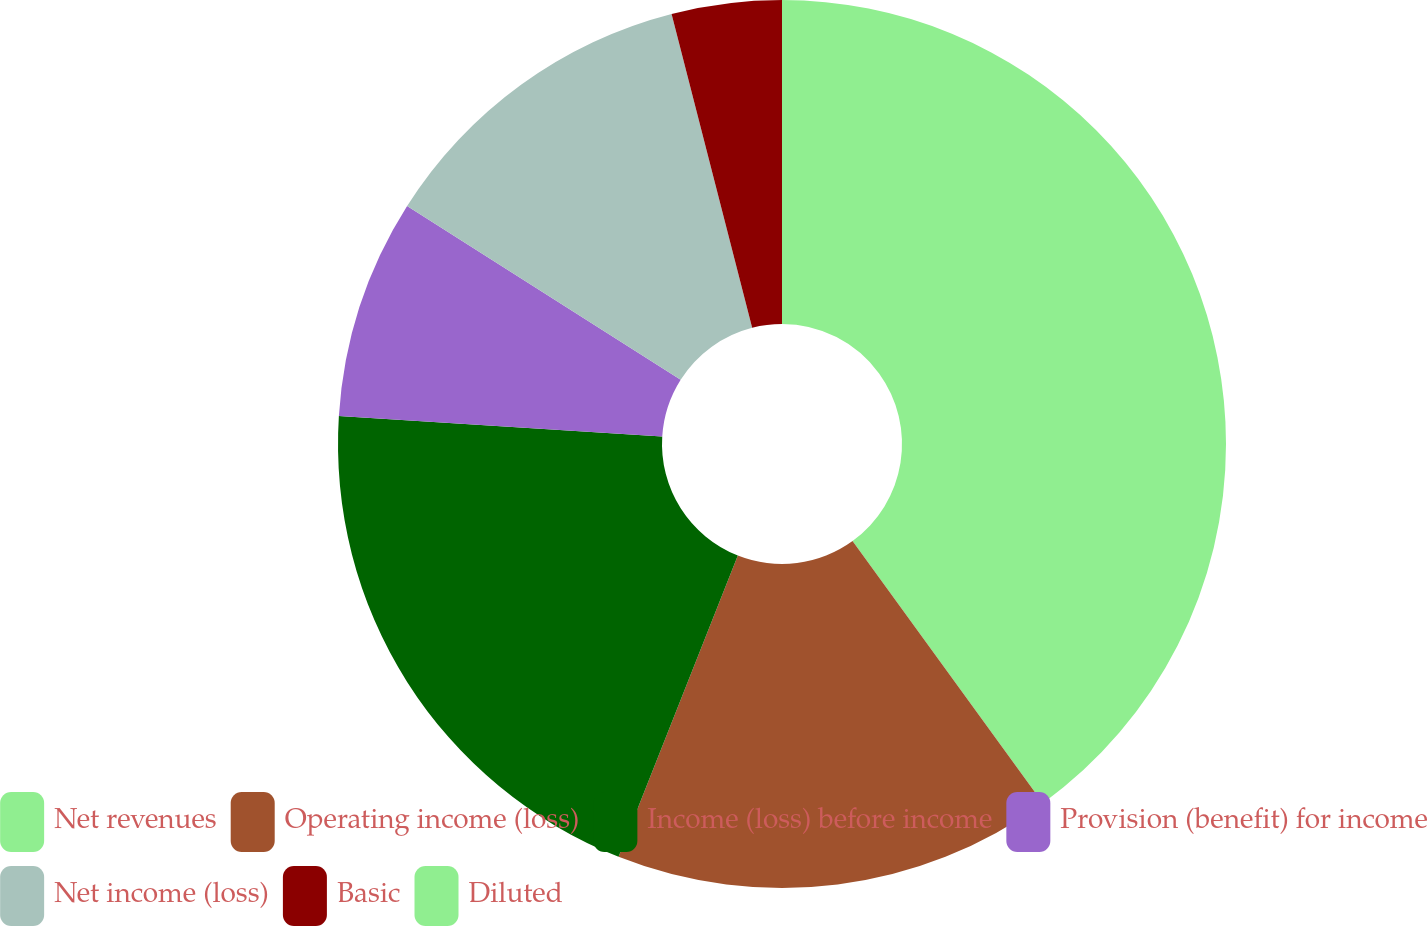Convert chart to OTSL. <chart><loc_0><loc_0><loc_500><loc_500><pie_chart><fcel>Net revenues<fcel>Operating income (loss)<fcel>Income (loss) before income<fcel>Provision (benefit) for income<fcel>Net income (loss)<fcel>Basic<fcel>Diluted<nl><fcel>40.0%<fcel>16.0%<fcel>20.0%<fcel>8.0%<fcel>12.0%<fcel>4.0%<fcel>0.0%<nl></chart> 